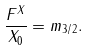Convert formula to latex. <formula><loc_0><loc_0><loc_500><loc_500>\frac { F ^ { X } } { X _ { 0 } } = m _ { 3 / 2 } .</formula> 